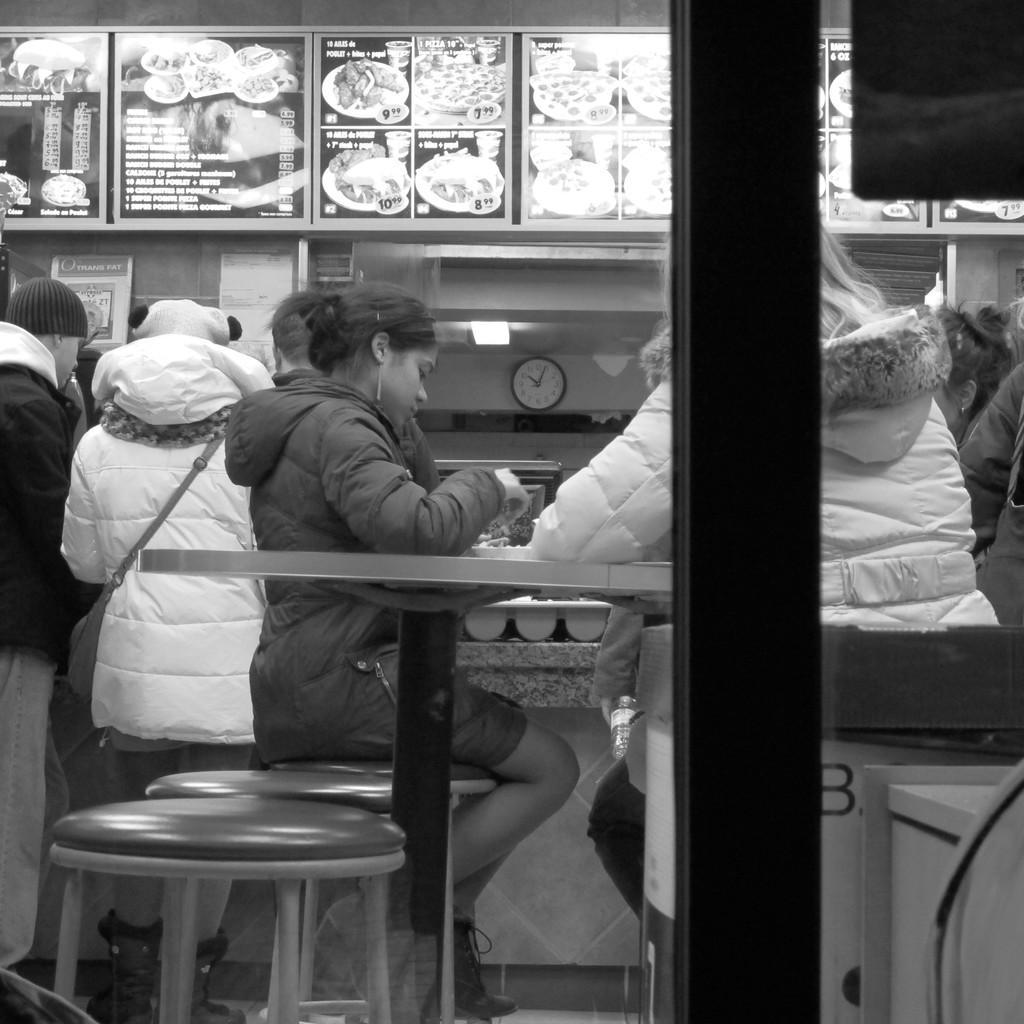Please provide a concise description of this image. This picture is clicked inside a hotel. Here, we see two people sitting on chair. Behind them, we see two men standing. Behind those people, we see a wall clock and a board on which items are displayed. 